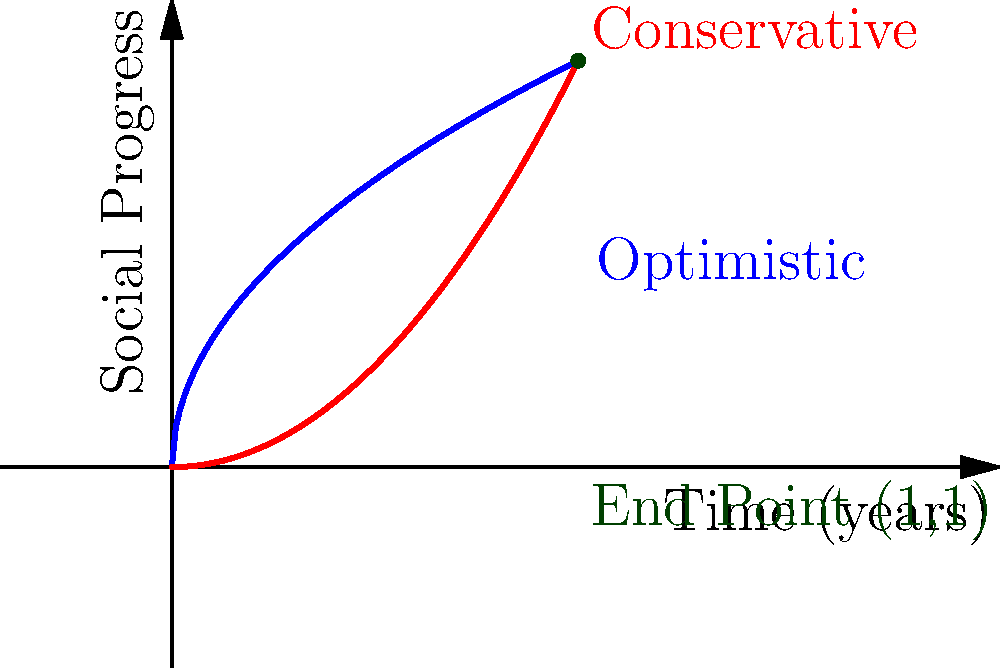In the spirit of Martin Luther King Jr.'s quote, "The arc of the moral universe is long, but it bends toward justice," consider two models of social progress over time: an optimistic model represented by $f(t)=\sqrt{t}$ and a conservative model represented by $g(t)=t^2$, where $t$ is time normalized from 0 to 1. If we represent social progress as a vector from $(0,0)$ to $(1,1)$ over this time period, what is the magnitude of this progress vector? To calculate the magnitude of the progress vector, we'll follow these steps:

1) The vector starts at $(0,0)$ and ends at $(1,1)$, regardless of the path taken.

2) The vector can be represented as $\vec{v} = \langle 1, 1 \rangle$.

3) The magnitude of a vector $\vec{v} = \langle a, b \rangle$ is given by the formula:

   $\|\vec{v}\| = \sqrt{a^2 + b^2}$

4) Substituting our values:

   $\|\vec{v}\| = \sqrt{1^2 + 1^2}$

5) Simplify:

   $\|\vec{v}\| = \sqrt{1 + 1} = \sqrt{2}$

6) $\sqrt{2}$ is approximately equal to 1.414213562.

This result shows that regardless of whether progress follows an optimistic or conservative path, the overall magnitude of change remains constant, emphasizing the importance of the end goal in social justice movements.
Answer: $\sqrt{2}$ 